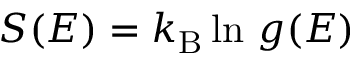Convert formula to latex. <formula><loc_0><loc_0><loc_500><loc_500>S ( E ) = k _ { B } \ln \, g ( E )</formula> 